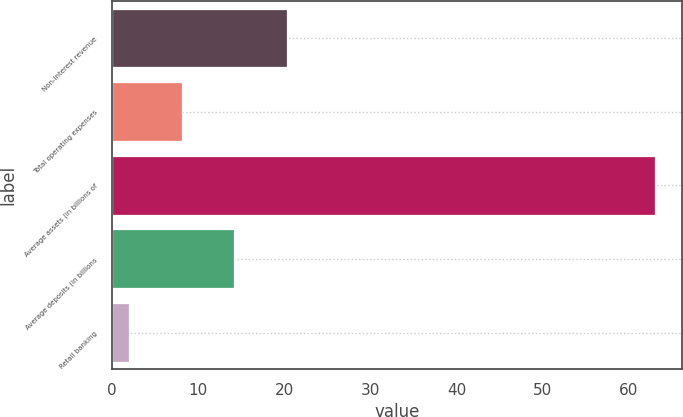Convert chart. <chart><loc_0><loc_0><loc_500><loc_500><bar_chart><fcel>Non-interest revenue<fcel>Total operating expenses<fcel>Average assets (in billions of<fcel>Average deposits (in billions<fcel>Retail banking<nl><fcel>20.3<fcel>8.1<fcel>63<fcel>14.2<fcel>2<nl></chart> 